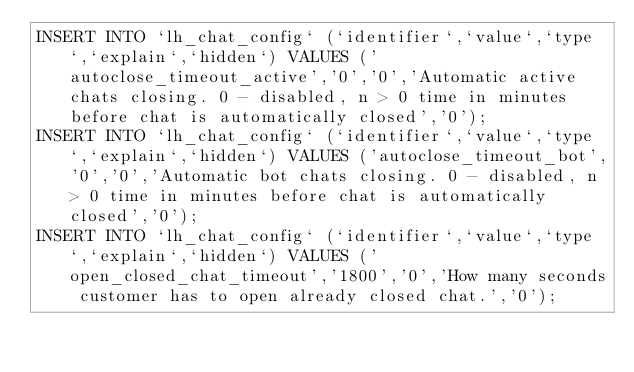Convert code to text. <code><loc_0><loc_0><loc_500><loc_500><_SQL_>INSERT INTO `lh_chat_config` (`identifier`,`value`,`type`,`explain`,`hidden`) VALUES ('autoclose_timeout_active','0','0','Automatic active chats closing. 0 - disabled, n > 0 time in minutes before chat is automatically closed','0');
INSERT INTO `lh_chat_config` (`identifier`,`value`,`type`,`explain`,`hidden`) VALUES ('autoclose_timeout_bot','0','0','Automatic bot chats closing. 0 - disabled, n > 0 time in minutes before chat is automatically closed','0');
INSERT INTO `lh_chat_config` (`identifier`,`value`,`type`,`explain`,`hidden`) VALUES ('open_closed_chat_timeout','1800','0','How many seconds customer has to open already closed chat.','0');</code> 